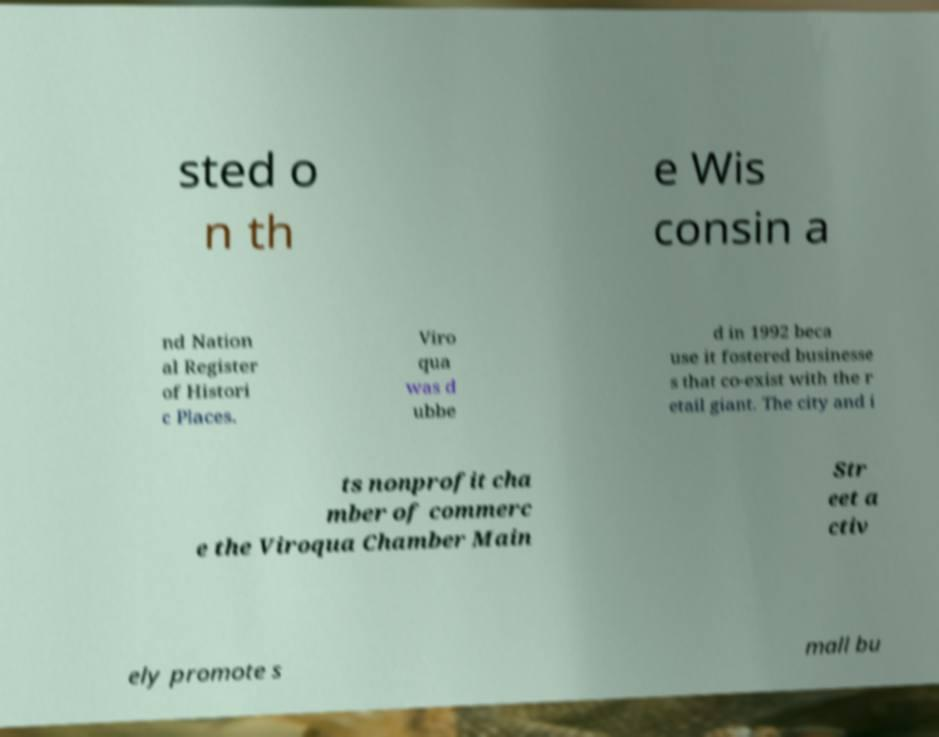Please identify and transcribe the text found in this image. sted o n th e Wis consin a nd Nation al Register of Histori c Places. Viro qua was d ubbe d in 1992 beca use it fostered businesse s that co-exist with the r etail giant. The city and i ts nonprofit cha mber of commerc e the Viroqua Chamber Main Str eet a ctiv ely promote s mall bu 